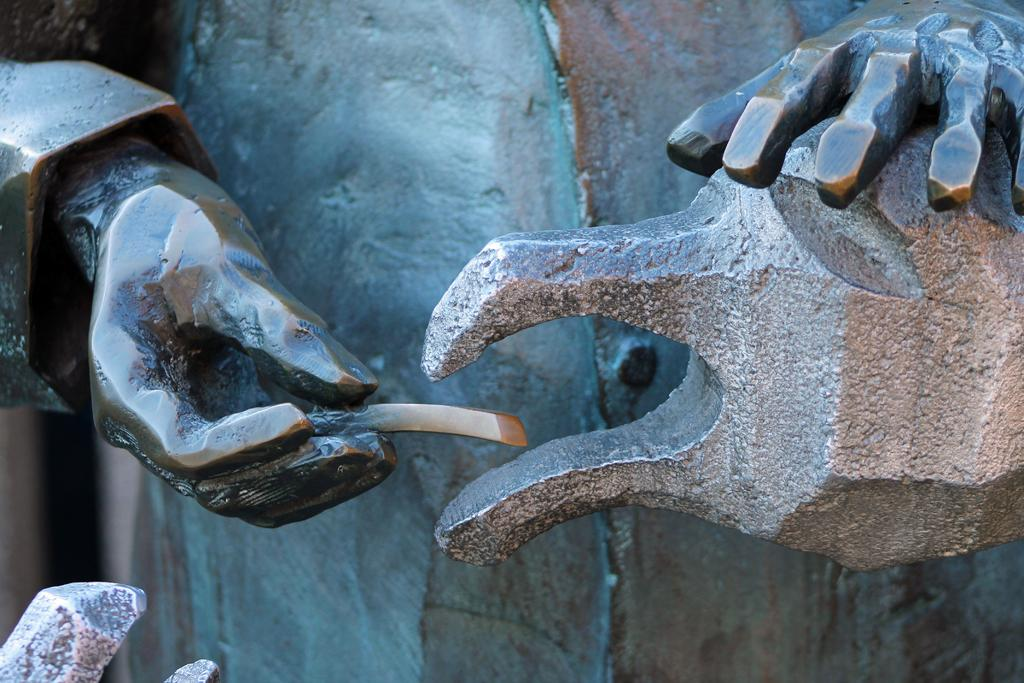What type of objects can be seen in the image? There are statues in the image. What type of organization is depicted in the image? There is no organization depicted in the image; it features statues. Is there a church visible in the image? There is no church present in the image. 